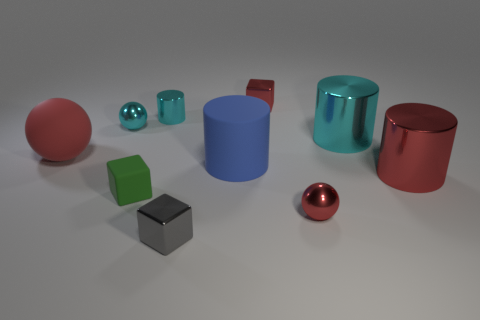Can you describe the position of the objects relative to the largest red cylinder? When observing the largest red cylinder, you will notice a small cyan ball to its right and slightly behind it. In front of the cylinder and a bit to the right lies a silver cube, while directly in front of it, there is a small, reflective red sphere. To the left of the red cylinder, there is a smaller blue cylinder and a green cube positioned close to each other. 